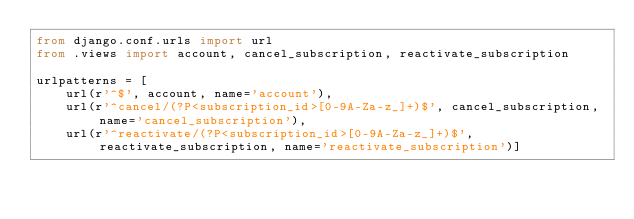Convert code to text. <code><loc_0><loc_0><loc_500><loc_500><_Python_>from django.conf.urls import url
from .views import account, cancel_subscription, reactivate_subscription

urlpatterns = [
    url(r'^$', account, name='account'),
    url(r'^cancel/(?P<subscription_id>[0-9A-Za-z_]+)$', cancel_subscription, name='cancel_subscription'),
    url(r'^reactivate/(?P<subscription_id>[0-9A-Za-z_]+)$', reactivate_subscription, name='reactivate_subscription')]</code> 